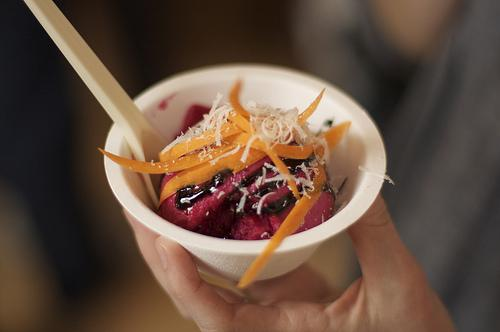Question: what is inside the small cup?
Choices:
A. Milk.
B. Food and spoon.
C. Beer.
D. Water.
Answer with the letter. Answer: B Question: where is the food?
Choices:
A. On a person's hand.
B. On the table.
C. On the stove.
D. In the refrigerator.
Answer with the letter. Answer: A Question: what kind of food is it?
Choices:
A. Ice cream.
B. Red pepper with slices of carrots.
C. Chicken.
D. Appetizers.
Answer with the letter. Answer: B 